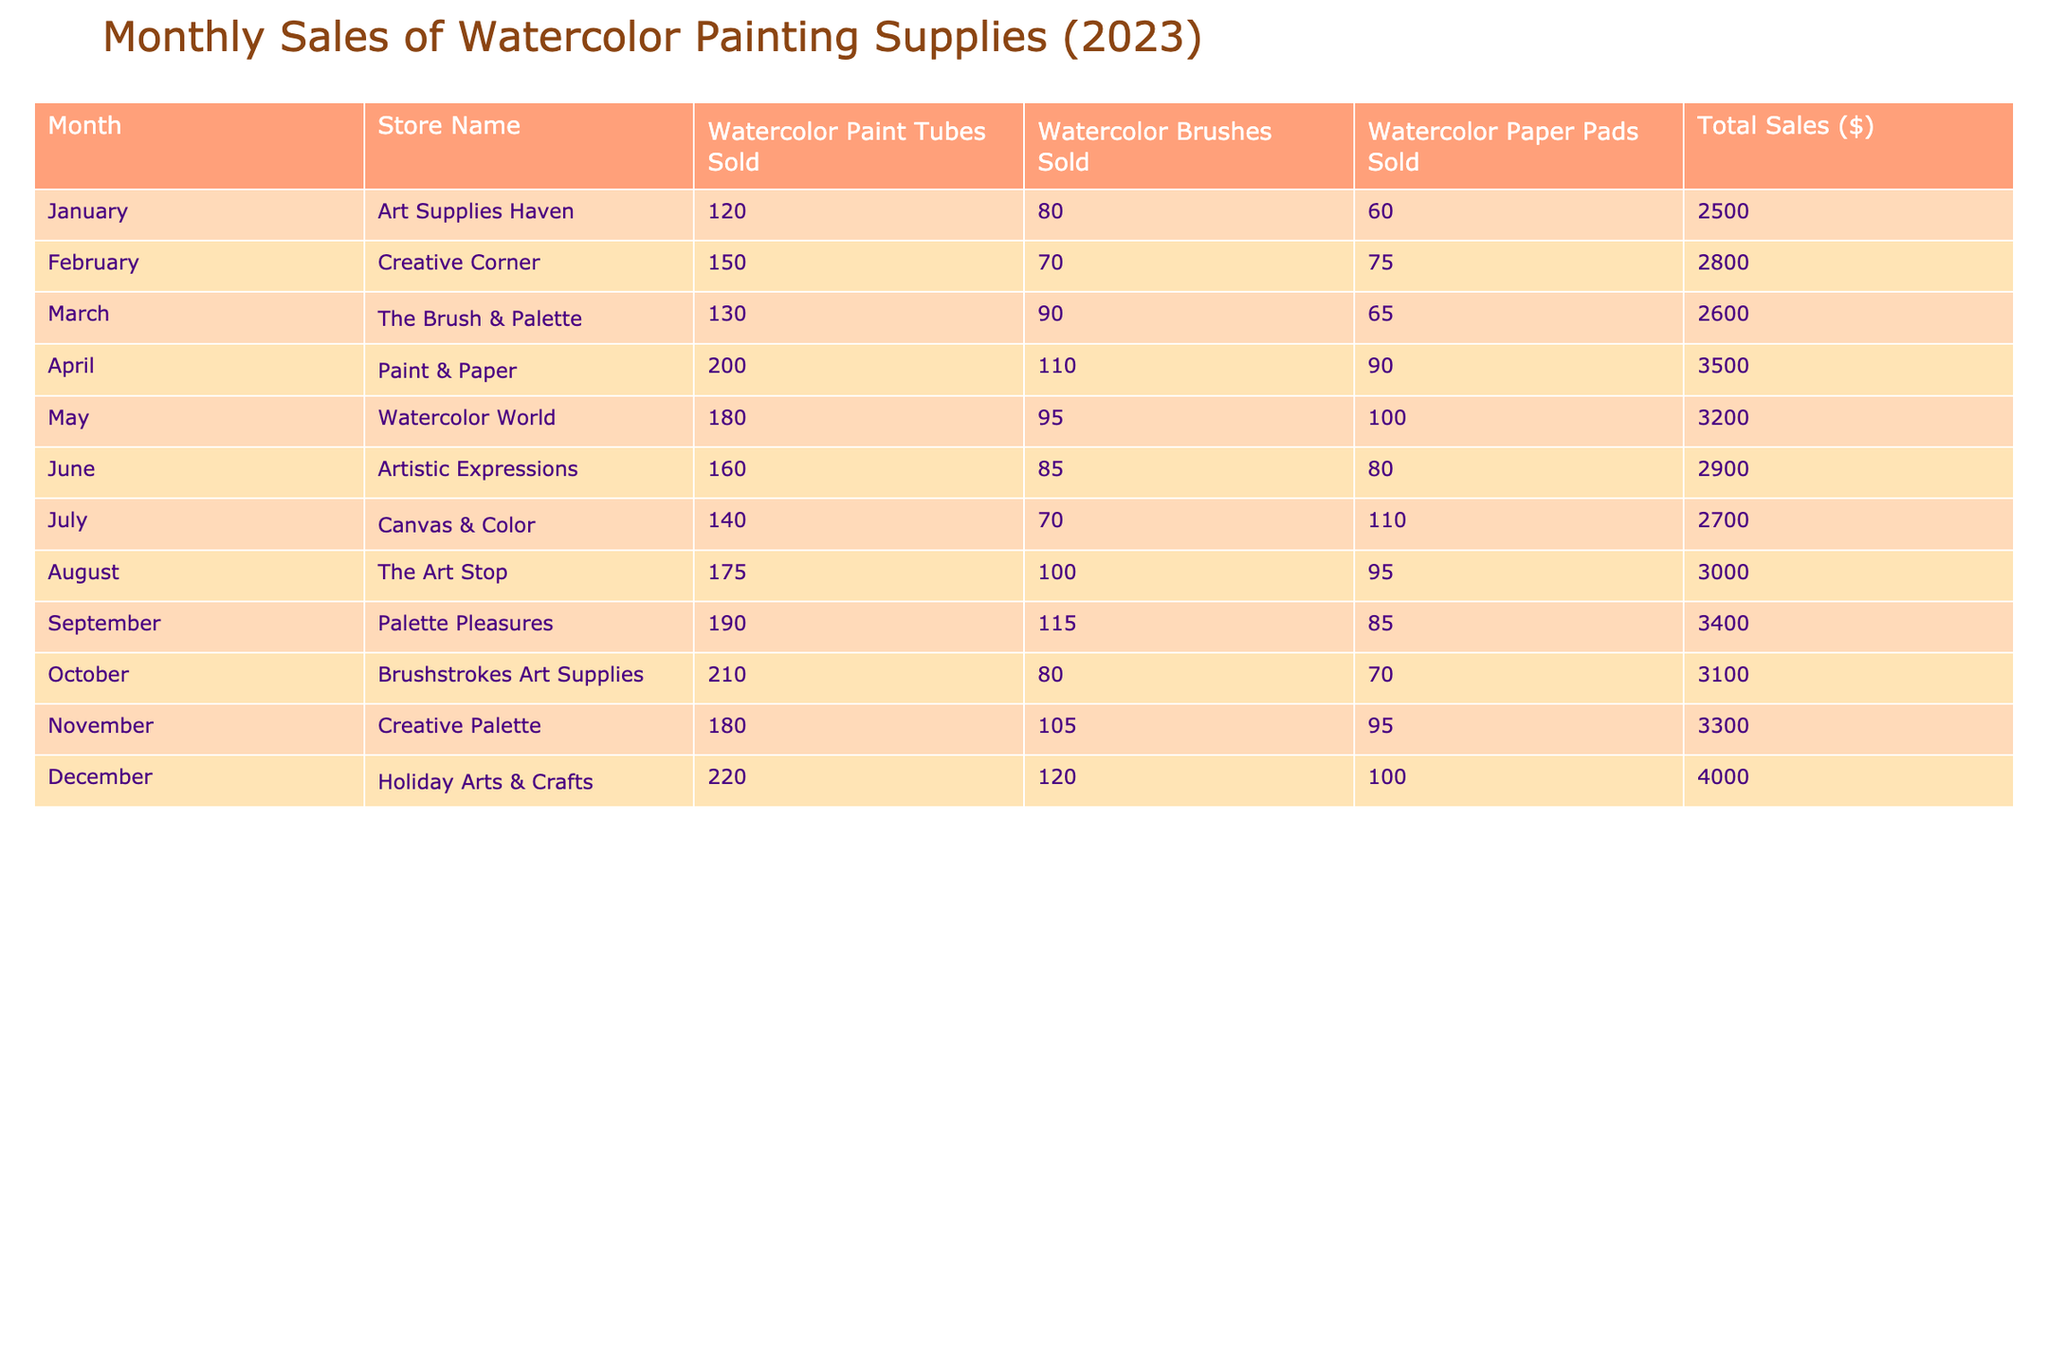What was the total sales amount for Holiday Arts & Crafts? The "Total Sales ($)" column shows that for December, the value corresponding to "Holiday Arts & Crafts" is 4000.
Answer: 4000 Which store sold the most watercolor paint tubes in April? Looking at April, the "Watercolor Paint Tubes Sold" column shows "Paint & Paper" with 200 tubes, which is the highest count for that month.
Answer: Paint & Paper How many watercolor brushes were sold in February? In the "February" row, the "Watercolor Brushes Sold" column indicates that 70 brushes were sold.
Answer: 70 What is the average total sales amount across all months? To find the average, we sum the total sales values: 2500 + 2800 + 2600 + 3500 + 3200 + 2900 + 2700 + 3000 + 3400 + 3100 + 3300 + 4000 = 36,000. There are 12 months, so the average is 36,000 / 12 = 3000.
Answer: 3000 Did Creative Palette have higher total sales than The Brush & Palette? "Creative Palette" had total sales of 3300 in November, while "The Brush & Palette" had total sales of 2600 in March. Since 3300 is greater than 2600, the answer is yes.
Answer: Yes Which month had the highest number of watercolor paper pads sold? By checking the "Watercolor Paper Pads Sold" column, December shows the highest number sold at 100 pads.
Answer: December How much more did sales increase from March to April? The total sales in March are 2600, while in April, they are 3500. The difference is 3500 - 2600 = 900.
Answer: 900 Were there any months where the number of watercolor brushes sold exceeded 100? Looking through the "Watercolor Brushes Sold" column, April, September, October, November, and December all show values greater than 100. Therefore, the answer is yes.
Answer: Yes What was the total number of watercolor paint tubes sold over the entire year? To find this, we sum the "Watercolor Paint Tubes Sold" for all months: 120 + 150 + 130 + 200 + 180 + 160 + 140 + 175 + 190 + 210 + 180 + 220 = 2,225.
Answer: 2,225 